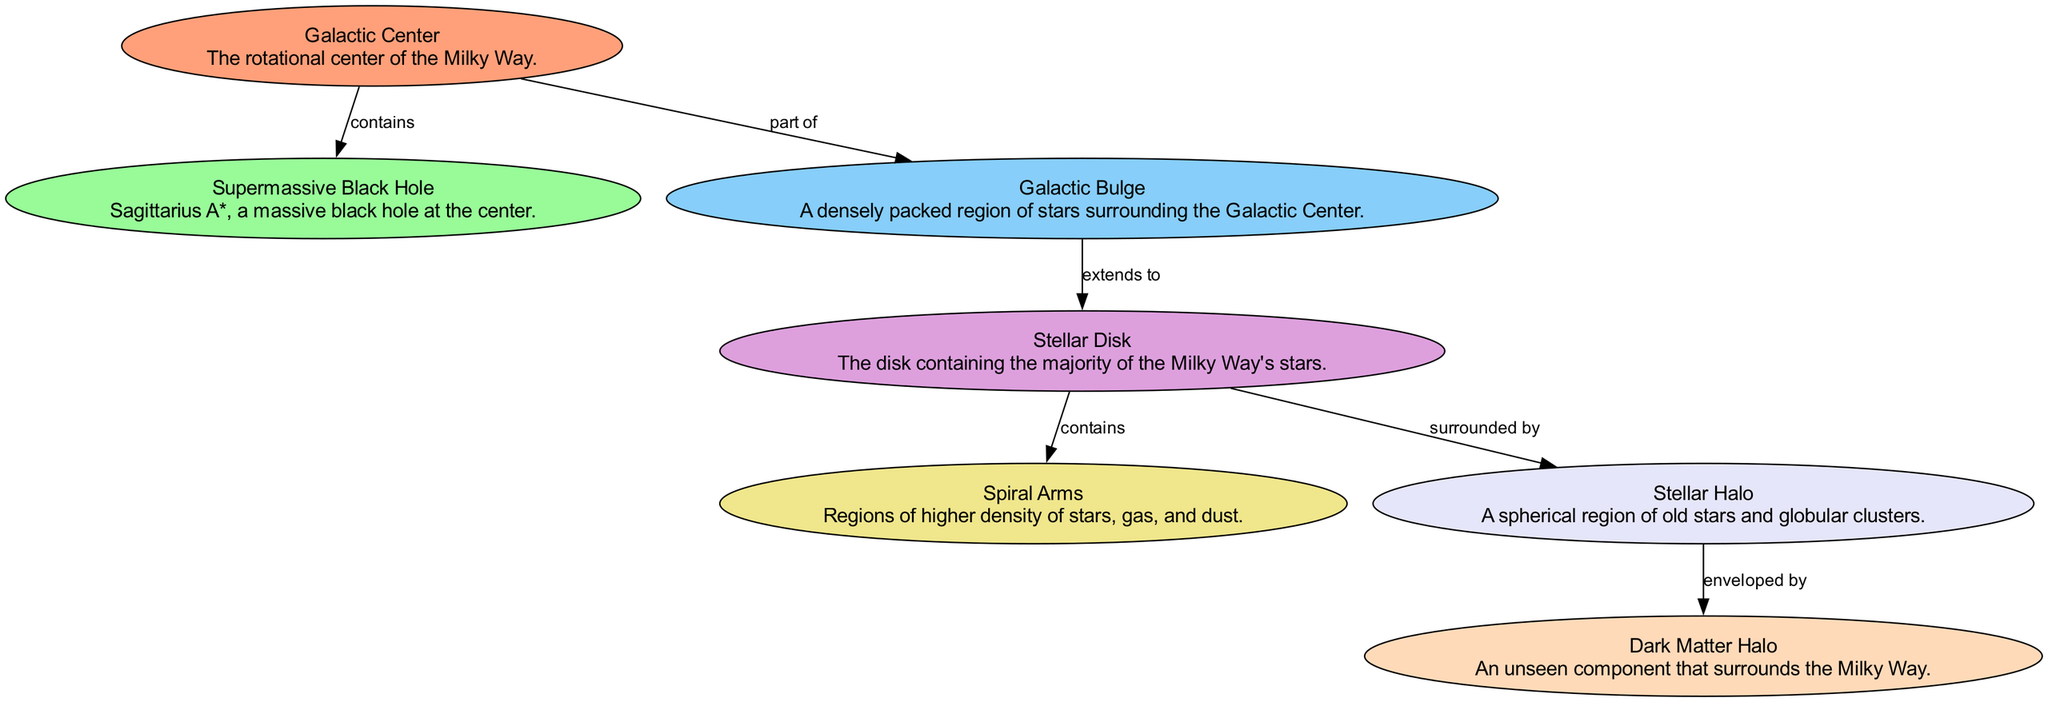What is the central component of the Milky Way Galaxy? The diagram specifically identifies the "Galactic Center" as the main central component of the Milky Way Galaxy.
Answer: Galactic Center What does the Galactic Center contain? According to the diagram, the Galactic Center contains a "Supermassive Black Hole", explicitly named Sagittarius A*.
Answer: Supermassive Black Hole How many main components are displayed in the diagram? By counting the nodes described in the diagram, we see there are a total of seven main components or nodes representing the structure of the Milky Way.
Answer: Seven What region extends from the Galactic Bulge? The diagram shows that the "Stellar Disk" extends from the "Galactic Bulge", depicting a direct relationship between these two components.
Answer: Stellar Disk Which component is surrounded by the Stellar Halo? The diagram indicates that the "Stellar Disk" is surrounded by the "Stellar Halo", demonstrating the spatial relationship between these two elements.
Answer: Stellar Disk What is the unseen component surrounding the Milky Way? The diagram identifies the "Dark Matter Halo" as the unseen component that envelops the Milky Way, highlighting its significance in the galaxy's structure.
Answer: Dark Matter Halo If the Stellar Halo is enveloped by another component, what is that component? The diagram shows that the "Dark Matter Halo" envelops the "Stellar Halo", indicating a surrounding relationship.
Answer: Dark Matter Halo What defines the areas of higher density in the Milky Way? The diagram describes "Spiral Arms" as the regions of higher density of stars, gas, and dust, characterizing their role within the galaxy.
Answer: Spiral Arms Which component is indicated as part of the Galactic Center? The diagram directly states that the "Galactic Bulge" is part of the "Galactic Center", indicating a close structural relationship.
Answer: Galactic Bulge 